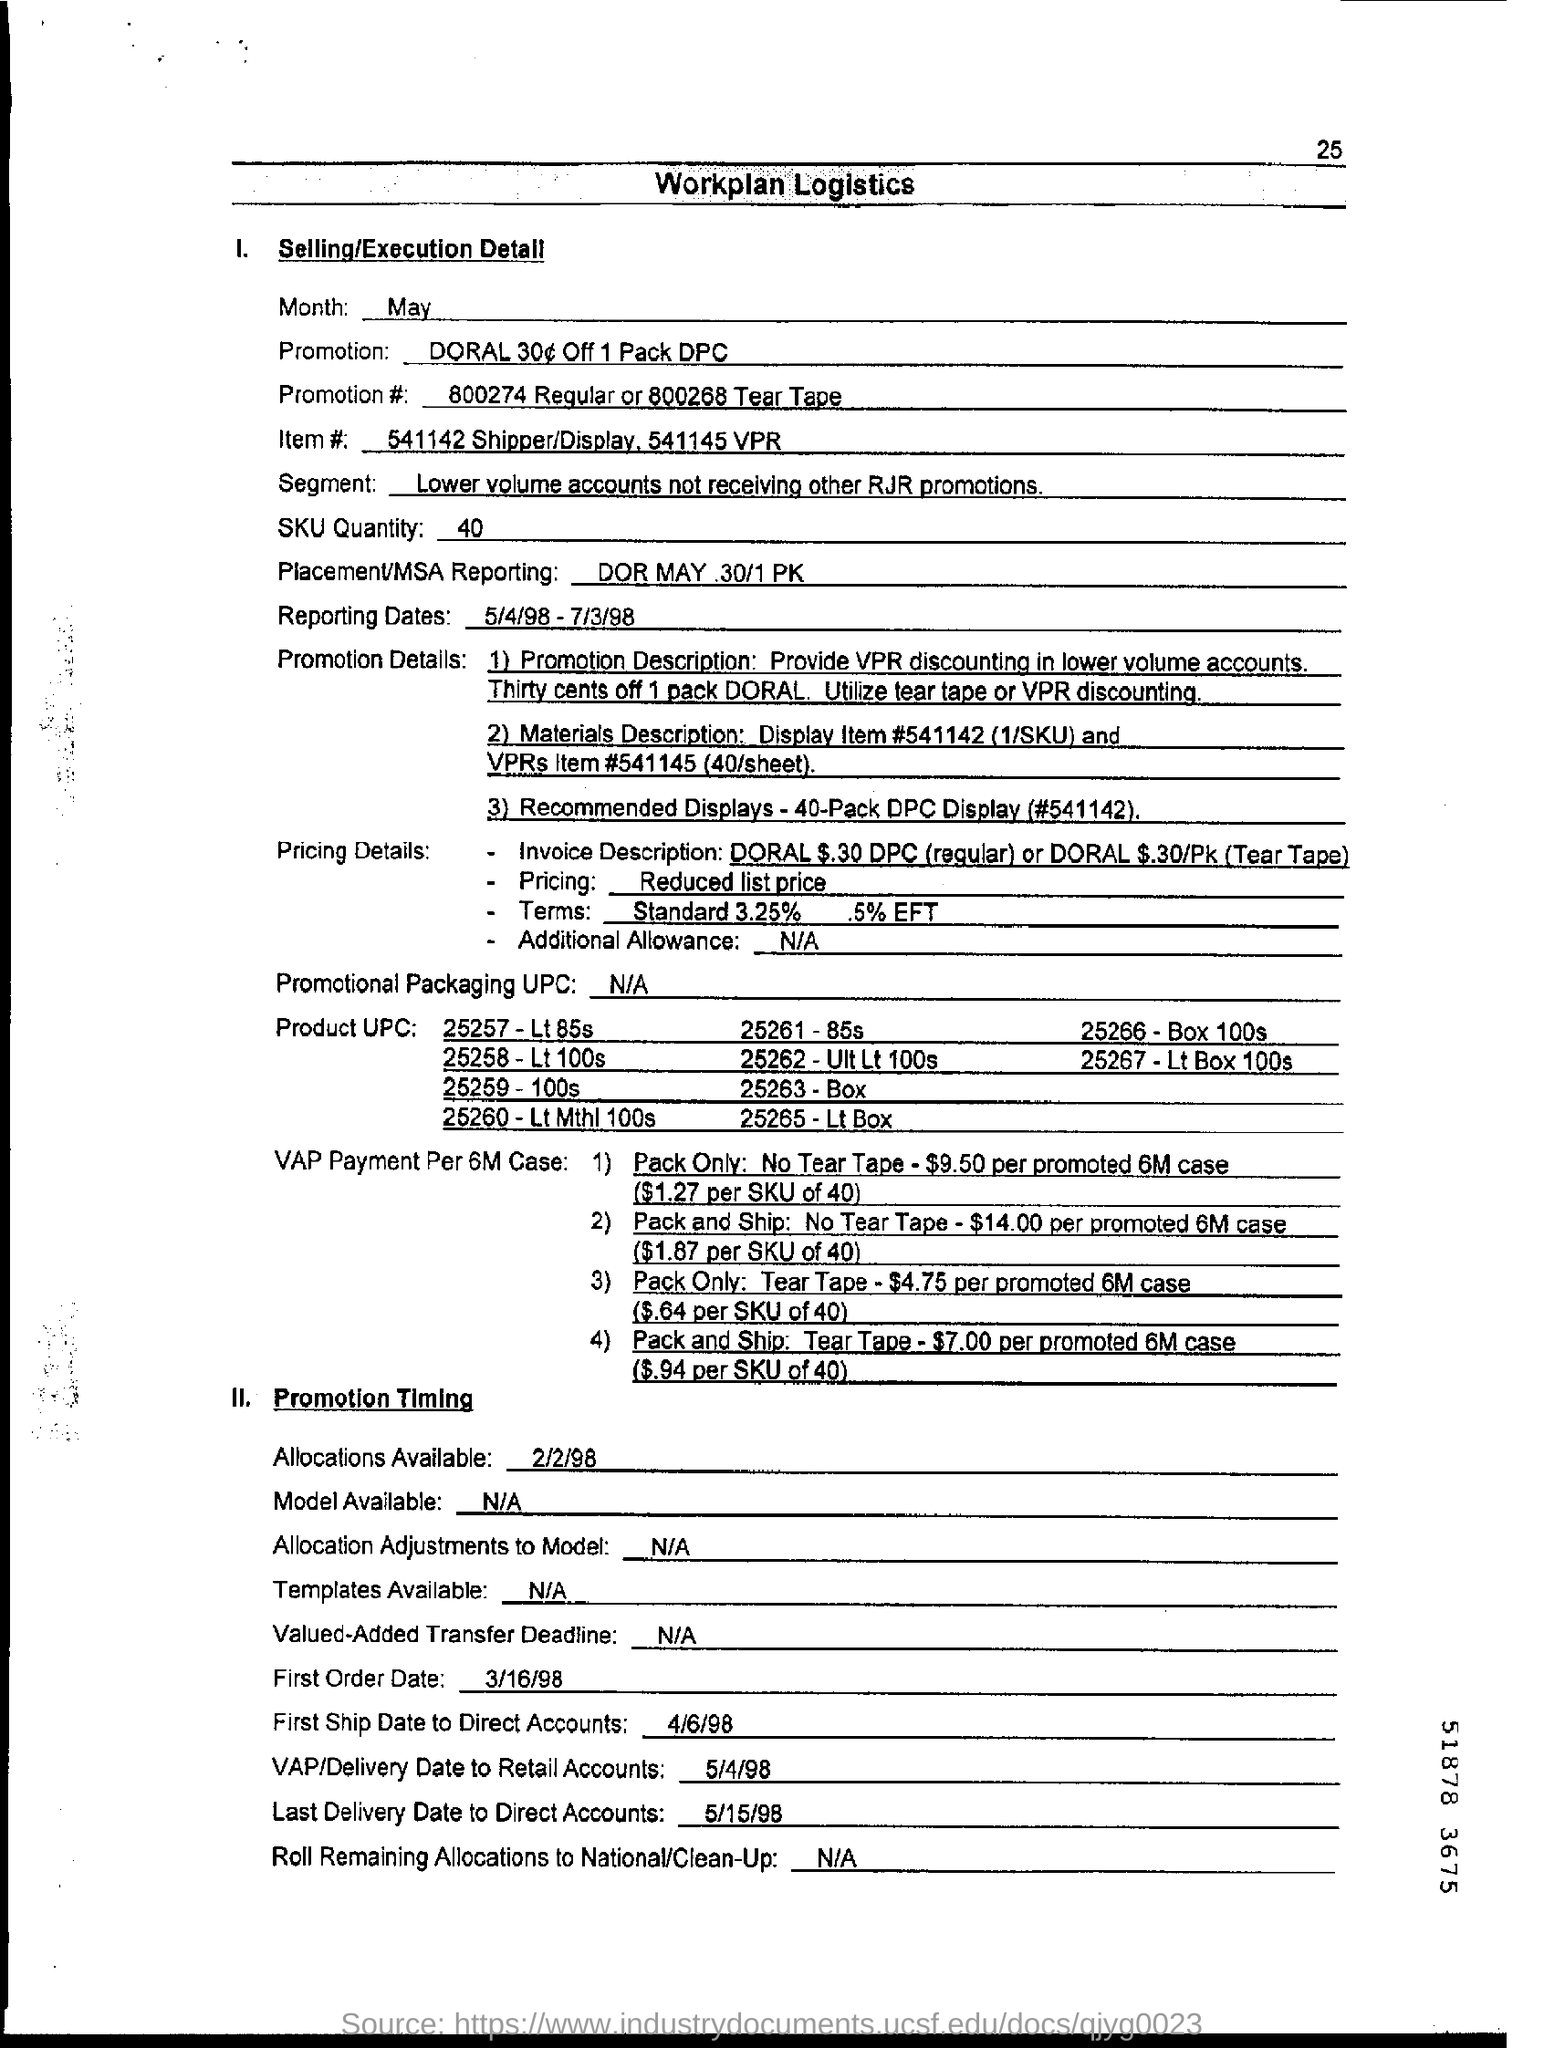List a handful of essential elements in this visual. The EFT percentage is 5%. The last delivery to direct accounts was on May 15, 1998. 